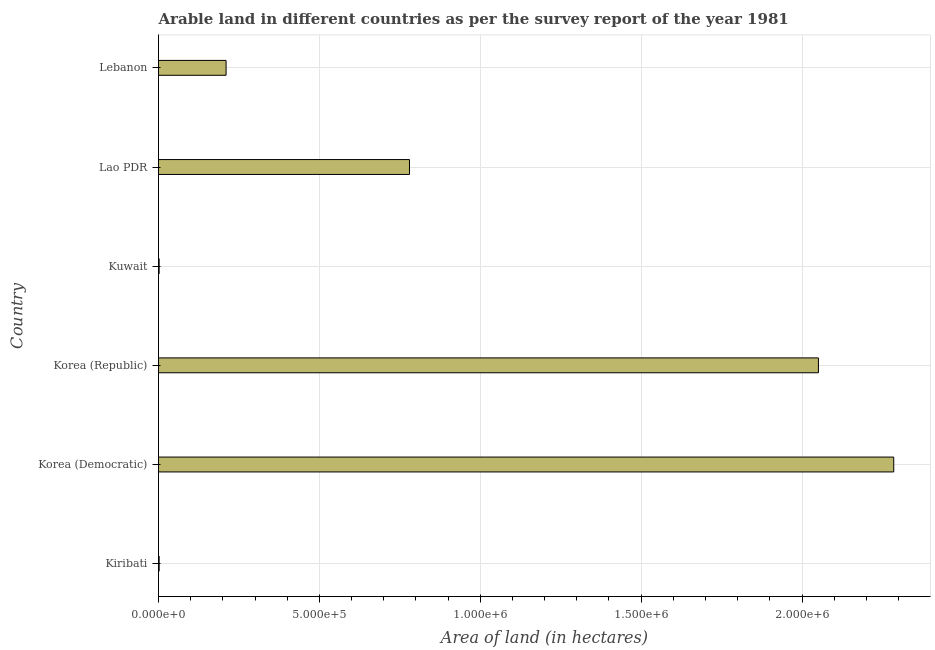Does the graph contain any zero values?
Your answer should be compact. No. Does the graph contain grids?
Your response must be concise. Yes. What is the title of the graph?
Keep it short and to the point. Arable land in different countries as per the survey report of the year 1981. What is the label or title of the X-axis?
Offer a terse response. Area of land (in hectares). What is the label or title of the Y-axis?
Give a very brief answer. Country. What is the area of land in Korea (Republic)?
Offer a terse response. 2.05e+06. Across all countries, what is the maximum area of land?
Offer a very short reply. 2.28e+06. In which country was the area of land maximum?
Keep it short and to the point. Korea (Democratic). In which country was the area of land minimum?
Provide a short and direct response. Kiribati. What is the sum of the area of land?
Make the answer very short. 5.33e+06. What is the difference between the area of land in Korea (Republic) and Lebanon?
Your answer should be very brief. 1.84e+06. What is the average area of land per country?
Offer a terse response. 8.88e+05. What is the median area of land?
Keep it short and to the point. 4.95e+05. Is the difference between the area of land in Korea (Democratic) and Lebanon greater than the difference between any two countries?
Your answer should be very brief. No. What is the difference between the highest and the second highest area of land?
Provide a succinct answer. 2.34e+05. What is the difference between the highest and the lowest area of land?
Keep it short and to the point. 2.28e+06. In how many countries, is the area of land greater than the average area of land taken over all countries?
Offer a very short reply. 2. How many bars are there?
Ensure brevity in your answer.  6. What is the difference between two consecutive major ticks on the X-axis?
Give a very brief answer. 5.00e+05. Are the values on the major ticks of X-axis written in scientific E-notation?
Provide a succinct answer. Yes. What is the Area of land (in hectares) of Kiribati?
Offer a terse response. 2000. What is the Area of land (in hectares) of Korea (Democratic)?
Ensure brevity in your answer.  2.28e+06. What is the Area of land (in hectares) in Korea (Republic)?
Offer a terse response. 2.05e+06. What is the Area of land (in hectares) in Lao PDR?
Give a very brief answer. 7.80e+05. What is the Area of land (in hectares) in Lebanon?
Ensure brevity in your answer.  2.10e+05. What is the difference between the Area of land (in hectares) in Kiribati and Korea (Democratic)?
Your response must be concise. -2.28e+06. What is the difference between the Area of land (in hectares) in Kiribati and Korea (Republic)?
Keep it short and to the point. -2.05e+06. What is the difference between the Area of land (in hectares) in Kiribati and Kuwait?
Your answer should be very brief. 0. What is the difference between the Area of land (in hectares) in Kiribati and Lao PDR?
Keep it short and to the point. -7.78e+05. What is the difference between the Area of land (in hectares) in Kiribati and Lebanon?
Provide a succinct answer. -2.08e+05. What is the difference between the Area of land (in hectares) in Korea (Democratic) and Korea (Republic)?
Your response must be concise. 2.34e+05. What is the difference between the Area of land (in hectares) in Korea (Democratic) and Kuwait?
Provide a succinct answer. 2.28e+06. What is the difference between the Area of land (in hectares) in Korea (Democratic) and Lao PDR?
Keep it short and to the point. 1.50e+06. What is the difference between the Area of land (in hectares) in Korea (Democratic) and Lebanon?
Provide a succinct answer. 2.08e+06. What is the difference between the Area of land (in hectares) in Korea (Republic) and Kuwait?
Provide a succinct answer. 2.05e+06. What is the difference between the Area of land (in hectares) in Korea (Republic) and Lao PDR?
Your answer should be very brief. 1.27e+06. What is the difference between the Area of land (in hectares) in Korea (Republic) and Lebanon?
Your answer should be compact. 1.84e+06. What is the difference between the Area of land (in hectares) in Kuwait and Lao PDR?
Keep it short and to the point. -7.78e+05. What is the difference between the Area of land (in hectares) in Kuwait and Lebanon?
Offer a very short reply. -2.08e+05. What is the difference between the Area of land (in hectares) in Lao PDR and Lebanon?
Offer a very short reply. 5.70e+05. What is the ratio of the Area of land (in hectares) in Kiribati to that in Korea (Democratic)?
Offer a very short reply. 0. What is the ratio of the Area of land (in hectares) in Kiribati to that in Lao PDR?
Give a very brief answer. 0. What is the ratio of the Area of land (in hectares) in Korea (Democratic) to that in Korea (Republic)?
Provide a succinct answer. 1.11. What is the ratio of the Area of land (in hectares) in Korea (Democratic) to that in Kuwait?
Offer a very short reply. 1142.5. What is the ratio of the Area of land (in hectares) in Korea (Democratic) to that in Lao PDR?
Your response must be concise. 2.93. What is the ratio of the Area of land (in hectares) in Korea (Democratic) to that in Lebanon?
Your answer should be very brief. 10.88. What is the ratio of the Area of land (in hectares) in Korea (Republic) to that in Kuwait?
Keep it short and to the point. 1025.5. What is the ratio of the Area of land (in hectares) in Korea (Republic) to that in Lao PDR?
Offer a terse response. 2.63. What is the ratio of the Area of land (in hectares) in Korea (Republic) to that in Lebanon?
Offer a terse response. 9.77. What is the ratio of the Area of land (in hectares) in Kuwait to that in Lao PDR?
Provide a short and direct response. 0. What is the ratio of the Area of land (in hectares) in Kuwait to that in Lebanon?
Provide a succinct answer. 0.01. What is the ratio of the Area of land (in hectares) in Lao PDR to that in Lebanon?
Give a very brief answer. 3.71. 